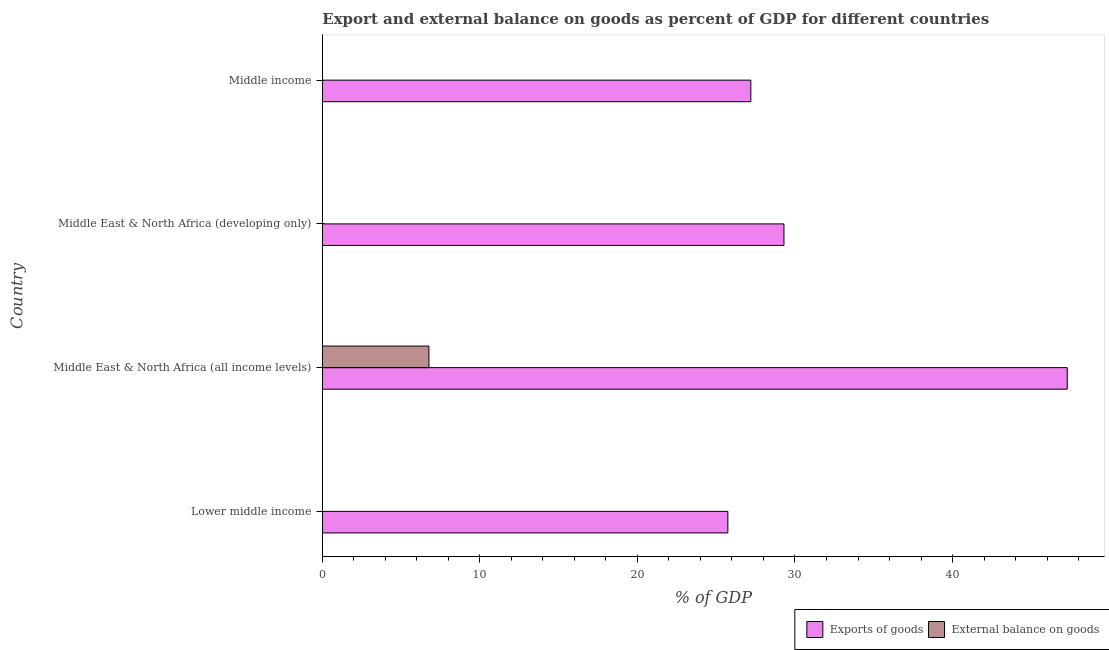Are the number of bars per tick equal to the number of legend labels?
Your answer should be compact. No. Are the number of bars on each tick of the Y-axis equal?
Offer a terse response. No. How many bars are there on the 4th tick from the top?
Provide a short and direct response. 1. How many bars are there on the 1st tick from the bottom?
Make the answer very short. 1. What is the label of the 4th group of bars from the top?
Offer a terse response. Lower middle income. What is the export of goods as percentage of gdp in Middle East & North Africa (developing only)?
Offer a terse response. 29.3. Across all countries, what is the maximum export of goods as percentage of gdp?
Ensure brevity in your answer.  47.28. Across all countries, what is the minimum external balance on goods as percentage of gdp?
Give a very brief answer. 0. In which country was the external balance on goods as percentage of gdp maximum?
Provide a succinct answer. Middle East & North Africa (all income levels). What is the total external balance on goods as percentage of gdp in the graph?
Give a very brief answer. 6.77. What is the difference between the export of goods as percentage of gdp in Middle East & North Africa (all income levels) and that in Middle income?
Your answer should be compact. 20.08. What is the difference between the external balance on goods as percentage of gdp in Lower middle income and the export of goods as percentage of gdp in Middle East & North Africa (developing only)?
Your response must be concise. -29.3. What is the average export of goods as percentage of gdp per country?
Offer a terse response. 32.38. What is the difference between the external balance on goods as percentage of gdp and export of goods as percentage of gdp in Middle East & North Africa (all income levels)?
Keep it short and to the point. -40.52. In how many countries, is the export of goods as percentage of gdp greater than 28 %?
Give a very brief answer. 2. What is the ratio of the export of goods as percentage of gdp in Middle East & North Africa (all income levels) to that in Middle income?
Your answer should be very brief. 1.74. What is the difference between the highest and the second highest export of goods as percentage of gdp?
Offer a very short reply. 17.98. What is the difference between the highest and the lowest external balance on goods as percentage of gdp?
Ensure brevity in your answer.  6.77. Is the sum of the export of goods as percentage of gdp in Middle East & North Africa (all income levels) and Middle income greater than the maximum external balance on goods as percentage of gdp across all countries?
Give a very brief answer. Yes. How many bars are there?
Your answer should be compact. 5. Are the values on the major ticks of X-axis written in scientific E-notation?
Ensure brevity in your answer.  No. Does the graph contain any zero values?
Give a very brief answer. Yes. Does the graph contain grids?
Your answer should be compact. No. How are the legend labels stacked?
Your answer should be very brief. Horizontal. What is the title of the graph?
Provide a short and direct response. Export and external balance on goods as percent of GDP for different countries. What is the label or title of the X-axis?
Provide a short and direct response. % of GDP. What is the % of GDP in Exports of goods in Lower middle income?
Make the answer very short. 25.74. What is the % of GDP in External balance on goods in Lower middle income?
Give a very brief answer. 0. What is the % of GDP of Exports of goods in Middle East & North Africa (all income levels)?
Offer a terse response. 47.28. What is the % of GDP in External balance on goods in Middle East & North Africa (all income levels)?
Make the answer very short. 6.77. What is the % of GDP in Exports of goods in Middle East & North Africa (developing only)?
Provide a short and direct response. 29.3. What is the % of GDP of Exports of goods in Middle income?
Your answer should be very brief. 27.2. Across all countries, what is the maximum % of GDP of Exports of goods?
Keep it short and to the point. 47.28. Across all countries, what is the maximum % of GDP of External balance on goods?
Give a very brief answer. 6.77. Across all countries, what is the minimum % of GDP in Exports of goods?
Make the answer very short. 25.74. What is the total % of GDP of Exports of goods in the graph?
Your answer should be very brief. 129.52. What is the total % of GDP in External balance on goods in the graph?
Your answer should be very brief. 6.77. What is the difference between the % of GDP in Exports of goods in Lower middle income and that in Middle East & North Africa (all income levels)?
Your response must be concise. -21.54. What is the difference between the % of GDP in Exports of goods in Lower middle income and that in Middle East & North Africa (developing only)?
Offer a very short reply. -3.56. What is the difference between the % of GDP of Exports of goods in Lower middle income and that in Middle income?
Give a very brief answer. -1.46. What is the difference between the % of GDP in Exports of goods in Middle East & North Africa (all income levels) and that in Middle East & North Africa (developing only)?
Your answer should be compact. 17.98. What is the difference between the % of GDP of Exports of goods in Middle East & North Africa (all income levels) and that in Middle income?
Offer a very short reply. 20.08. What is the difference between the % of GDP in Exports of goods in Middle East & North Africa (developing only) and that in Middle income?
Keep it short and to the point. 2.1. What is the difference between the % of GDP of Exports of goods in Lower middle income and the % of GDP of External balance on goods in Middle East & North Africa (all income levels)?
Your answer should be very brief. 18.97. What is the average % of GDP of Exports of goods per country?
Provide a short and direct response. 32.38. What is the average % of GDP of External balance on goods per country?
Keep it short and to the point. 1.69. What is the difference between the % of GDP in Exports of goods and % of GDP in External balance on goods in Middle East & North Africa (all income levels)?
Your response must be concise. 40.51. What is the ratio of the % of GDP in Exports of goods in Lower middle income to that in Middle East & North Africa (all income levels)?
Offer a terse response. 0.54. What is the ratio of the % of GDP in Exports of goods in Lower middle income to that in Middle East & North Africa (developing only)?
Your answer should be compact. 0.88. What is the ratio of the % of GDP of Exports of goods in Lower middle income to that in Middle income?
Provide a short and direct response. 0.95. What is the ratio of the % of GDP in Exports of goods in Middle East & North Africa (all income levels) to that in Middle East & North Africa (developing only)?
Give a very brief answer. 1.61. What is the ratio of the % of GDP in Exports of goods in Middle East & North Africa (all income levels) to that in Middle income?
Keep it short and to the point. 1.74. What is the ratio of the % of GDP of Exports of goods in Middle East & North Africa (developing only) to that in Middle income?
Your response must be concise. 1.08. What is the difference between the highest and the second highest % of GDP in Exports of goods?
Offer a terse response. 17.98. What is the difference between the highest and the lowest % of GDP of Exports of goods?
Make the answer very short. 21.54. What is the difference between the highest and the lowest % of GDP of External balance on goods?
Keep it short and to the point. 6.77. 